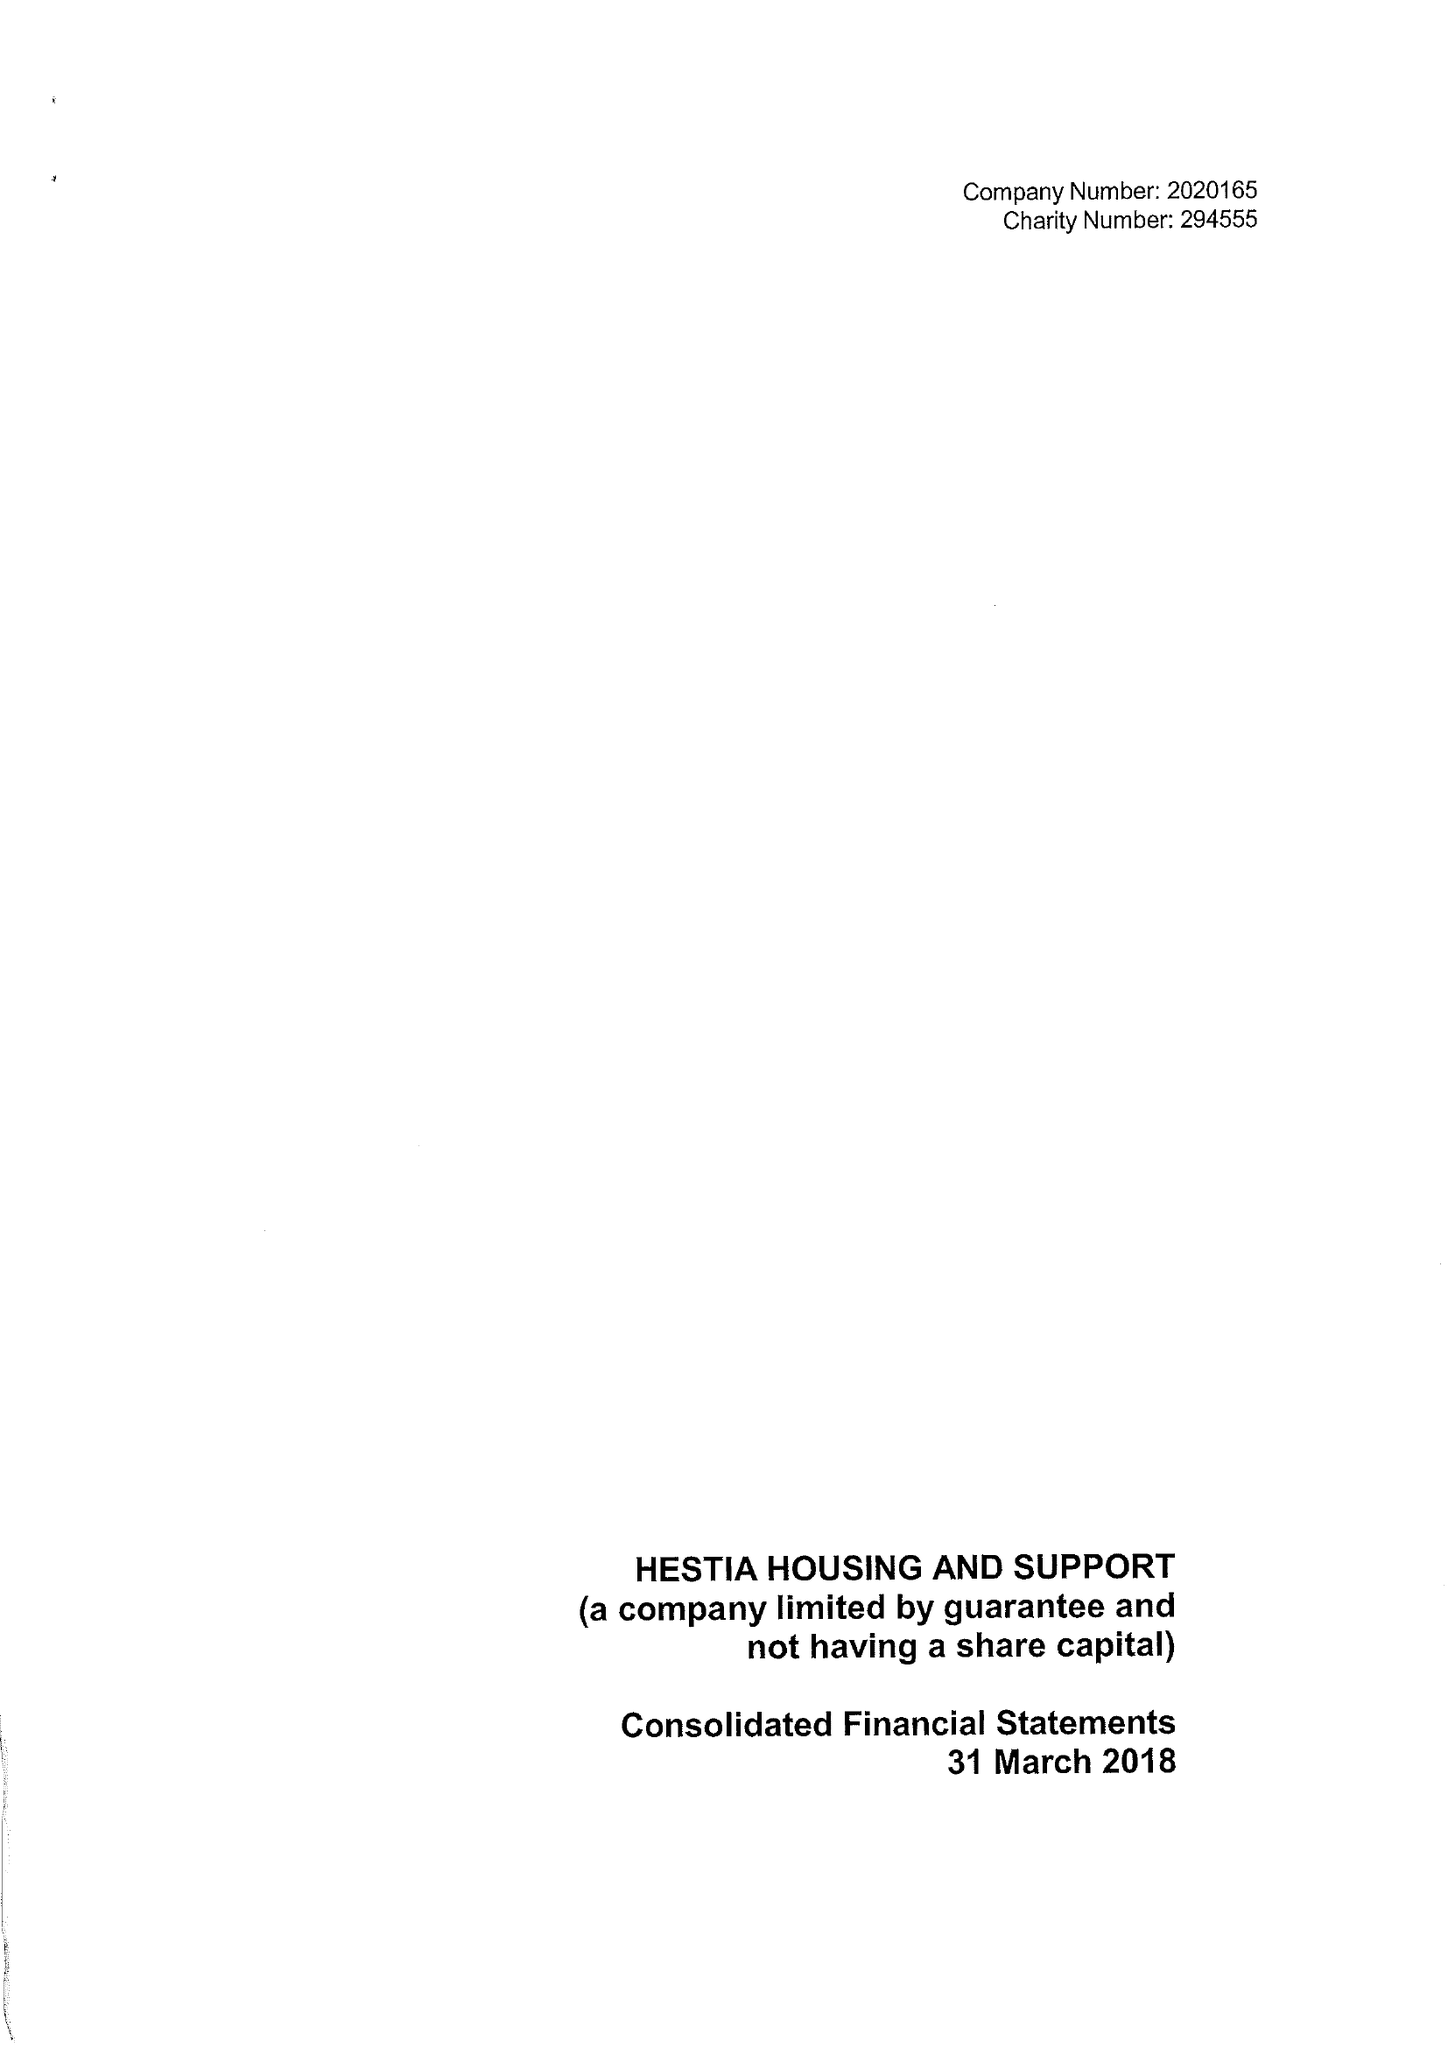What is the value for the address__post_town?
Answer the question using a single word or phrase. LONDON 